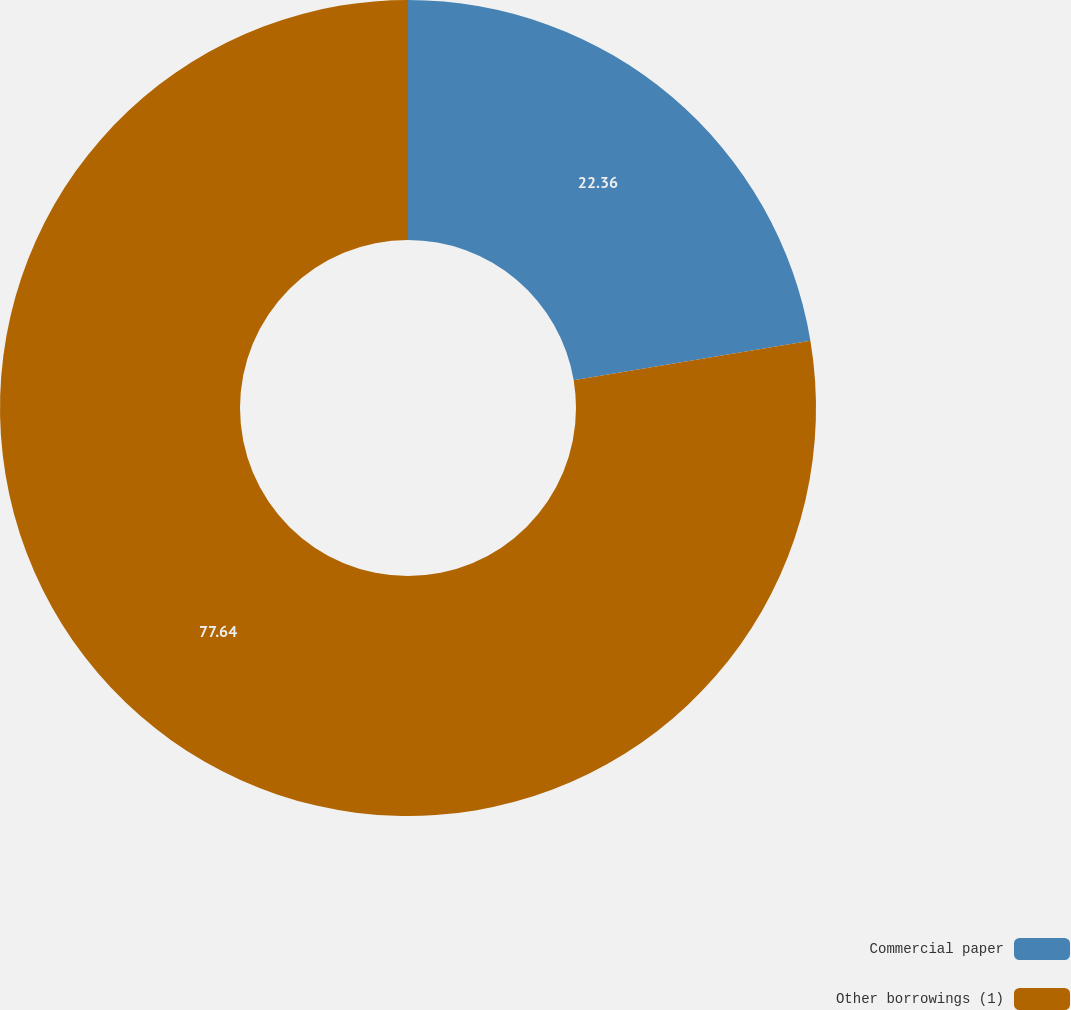Convert chart. <chart><loc_0><loc_0><loc_500><loc_500><pie_chart><fcel>Commercial paper<fcel>Other borrowings (1)<nl><fcel>22.36%<fcel>77.64%<nl></chart> 